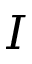Convert formula to latex. <formula><loc_0><loc_0><loc_500><loc_500>I</formula> 